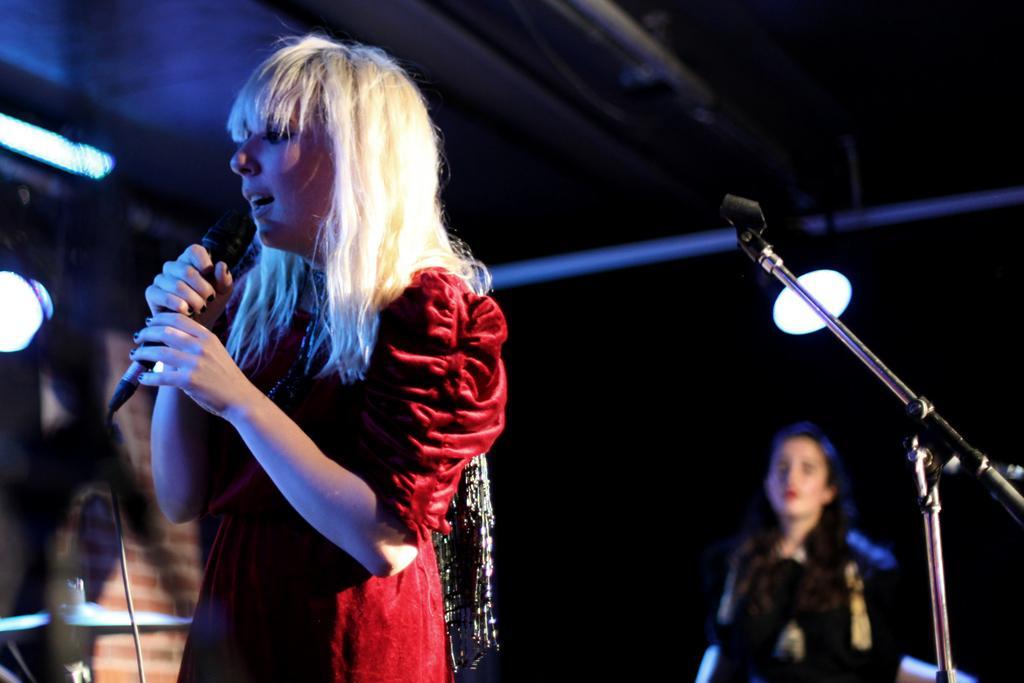How would you summarize this image in a sentence or two? In the image we can see there is a woman who is standing and holding mic in her hand and at the back there is another woman standing and the image is little blurry. 